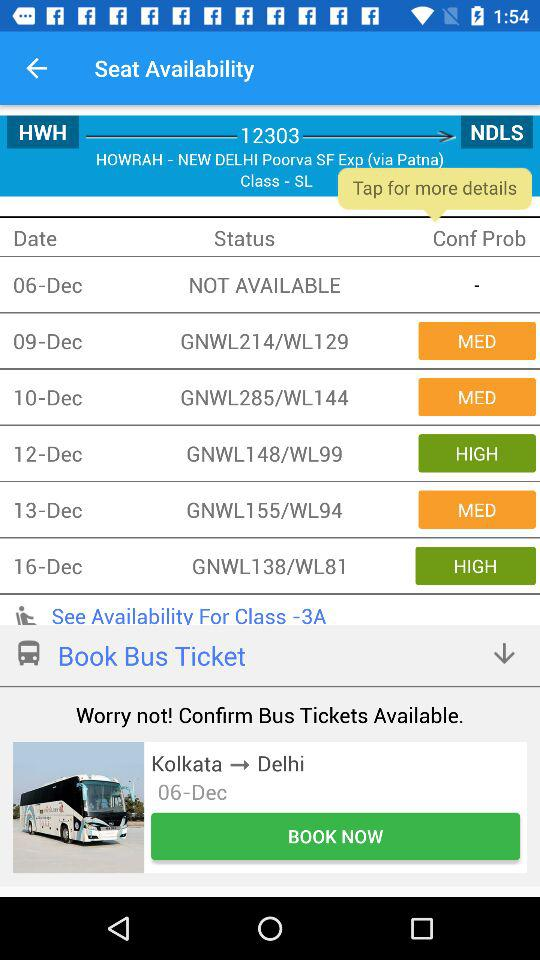Are bus tickets available for December 6 from Kolkata to Delhi? The bus tickets for December 6 are not available. 